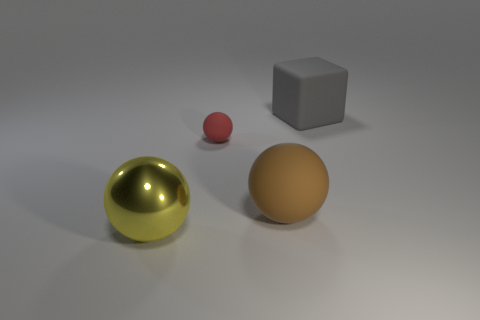Add 3 small yellow matte blocks. How many objects exist? 7 Subtract all cubes. How many objects are left? 3 Add 3 rubber cubes. How many rubber cubes exist? 4 Subtract 0 red blocks. How many objects are left? 4 Subtract all big brown spheres. Subtract all yellow cylinders. How many objects are left? 3 Add 4 balls. How many balls are left? 7 